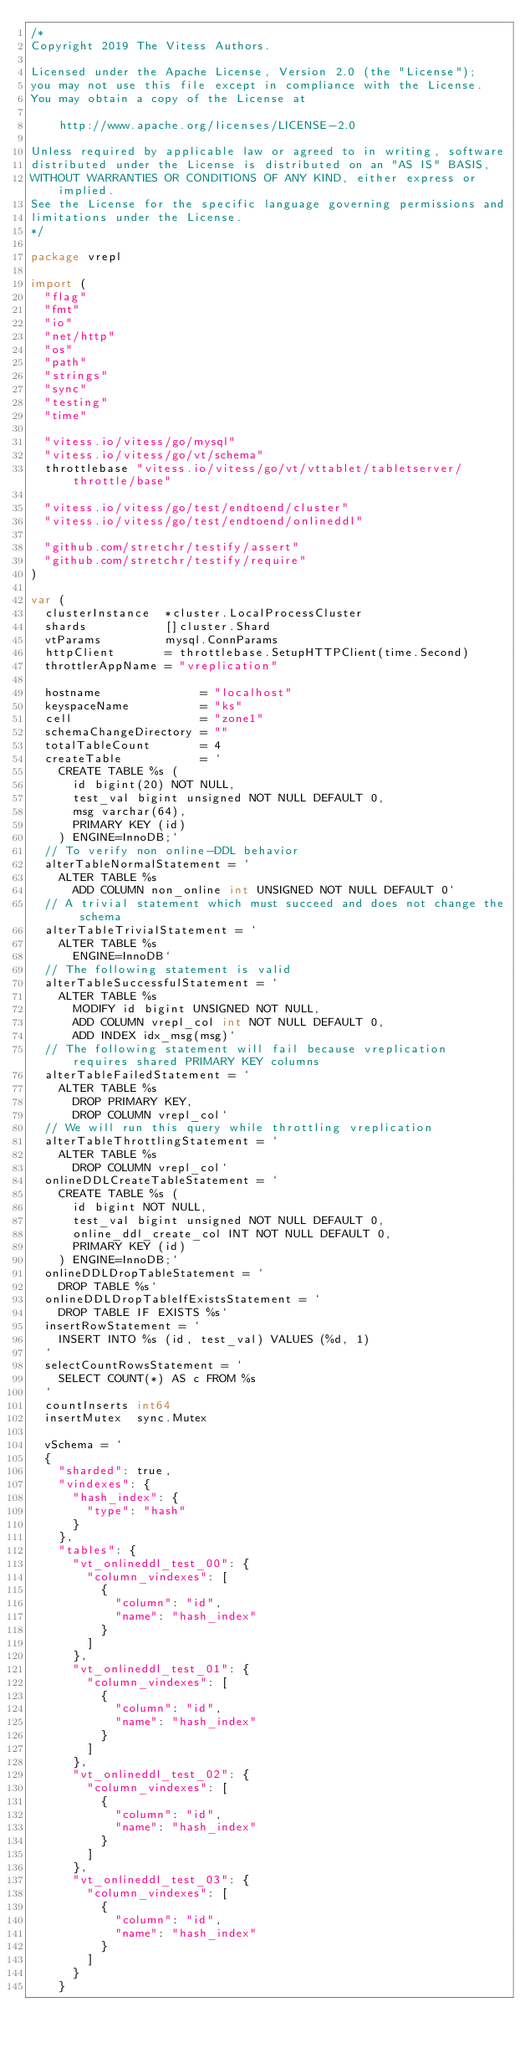Convert code to text. <code><loc_0><loc_0><loc_500><loc_500><_Go_>/*
Copyright 2019 The Vitess Authors.

Licensed under the Apache License, Version 2.0 (the "License");
you may not use this file except in compliance with the License.
You may obtain a copy of the License at

    http://www.apache.org/licenses/LICENSE-2.0

Unless required by applicable law or agreed to in writing, software
distributed under the License is distributed on an "AS IS" BASIS,
WITHOUT WARRANTIES OR CONDITIONS OF ANY KIND, either express or implied.
See the License for the specific language governing permissions and
limitations under the License.
*/

package vrepl

import (
	"flag"
	"fmt"
	"io"
	"net/http"
	"os"
	"path"
	"strings"
	"sync"
	"testing"
	"time"

	"vitess.io/vitess/go/mysql"
	"vitess.io/vitess/go/vt/schema"
	throttlebase "vitess.io/vitess/go/vt/vttablet/tabletserver/throttle/base"

	"vitess.io/vitess/go/test/endtoend/cluster"
	"vitess.io/vitess/go/test/endtoend/onlineddl"

	"github.com/stretchr/testify/assert"
	"github.com/stretchr/testify/require"
)

var (
	clusterInstance  *cluster.LocalProcessCluster
	shards           []cluster.Shard
	vtParams         mysql.ConnParams
	httpClient       = throttlebase.SetupHTTPClient(time.Second)
	throttlerAppName = "vreplication"

	hostname              = "localhost"
	keyspaceName          = "ks"
	cell                  = "zone1"
	schemaChangeDirectory = ""
	totalTableCount       = 4
	createTable           = `
		CREATE TABLE %s (
			id bigint(20) NOT NULL,
			test_val bigint unsigned NOT NULL DEFAULT 0,
			msg varchar(64),
			PRIMARY KEY (id)
		) ENGINE=InnoDB;`
	// To verify non online-DDL behavior
	alterTableNormalStatement = `
		ALTER TABLE %s
			ADD COLUMN non_online int UNSIGNED NOT NULL DEFAULT 0`
	// A trivial statement which must succeed and does not change the schema
	alterTableTrivialStatement = `
		ALTER TABLE %s
			ENGINE=InnoDB`
	// The following statement is valid
	alterTableSuccessfulStatement = `
		ALTER TABLE %s
			MODIFY id bigint UNSIGNED NOT NULL,
			ADD COLUMN vrepl_col int NOT NULL DEFAULT 0,
			ADD INDEX idx_msg(msg)`
	// The following statement will fail because vreplication requires shared PRIMARY KEY columns
	alterTableFailedStatement = `
		ALTER TABLE %s
			DROP PRIMARY KEY,
			DROP COLUMN vrepl_col`
	// We will run this query while throttling vreplication
	alterTableThrottlingStatement = `
		ALTER TABLE %s
			DROP COLUMN vrepl_col`
	onlineDDLCreateTableStatement = `
		CREATE TABLE %s (
			id bigint NOT NULL,
			test_val bigint unsigned NOT NULL DEFAULT 0,
			online_ddl_create_col INT NOT NULL DEFAULT 0,
			PRIMARY KEY (id)
		) ENGINE=InnoDB;`
	onlineDDLDropTableStatement = `
		DROP TABLE %s`
	onlineDDLDropTableIfExistsStatement = `
		DROP TABLE IF EXISTS %s`
	insertRowStatement = `
		INSERT INTO %s (id, test_val) VALUES (%d, 1)
	`
	selectCountRowsStatement = `
		SELECT COUNT(*) AS c FROM %s
	`
	countInserts int64
	insertMutex  sync.Mutex

	vSchema = `
	{
		"sharded": true,
		"vindexes": {
			"hash_index": {
				"type": "hash"
			}
		},
		"tables": {
			"vt_onlineddl_test_00": {
				"column_vindexes": [
					{
						"column": "id",
						"name": "hash_index"
					}
				]
			},
			"vt_onlineddl_test_01": {
				"column_vindexes": [
					{
						"column": "id",
						"name": "hash_index"
					}
				]
			},
			"vt_onlineddl_test_02": {
				"column_vindexes": [
					{
						"column": "id",
						"name": "hash_index"
					}
				]
			},
			"vt_onlineddl_test_03": {
				"column_vindexes": [
					{
						"column": "id",
						"name": "hash_index"
					}
				]
			}
		}</code> 